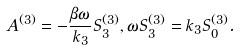Convert formula to latex. <formula><loc_0><loc_0><loc_500><loc_500>A ^ { ( 3 ) } = - \frac { \beta \omega } { k _ { 3 } } S ^ { ( 3 ) } _ { 3 } , \omega S ^ { ( 3 ) } _ { 3 } = k _ { 3 } S ^ { ( 3 ) } _ { 0 } .</formula> 